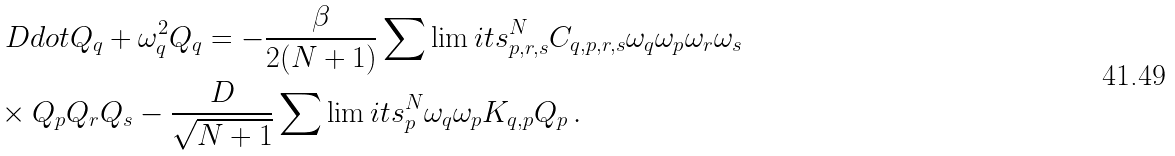<formula> <loc_0><loc_0><loc_500><loc_500>& \ D d o t { Q } _ { q } + \omega _ { q } ^ { 2 } Q _ { q } = - \frac { \beta } { 2 ( N + 1 ) } \sum \lim i t s _ { p , r , s } ^ { N } C _ { q , p , r , s } \omega _ { q } \omega _ { p } \omega _ { r } \omega _ { s } \\ & \times Q _ { p } Q _ { r } Q _ { s } - \frac { D } { \sqrt { N + 1 } } \sum \lim i t s _ { p } ^ { N } \omega _ { q } \omega _ { p } K _ { q , p } Q _ { p } \, .</formula> 